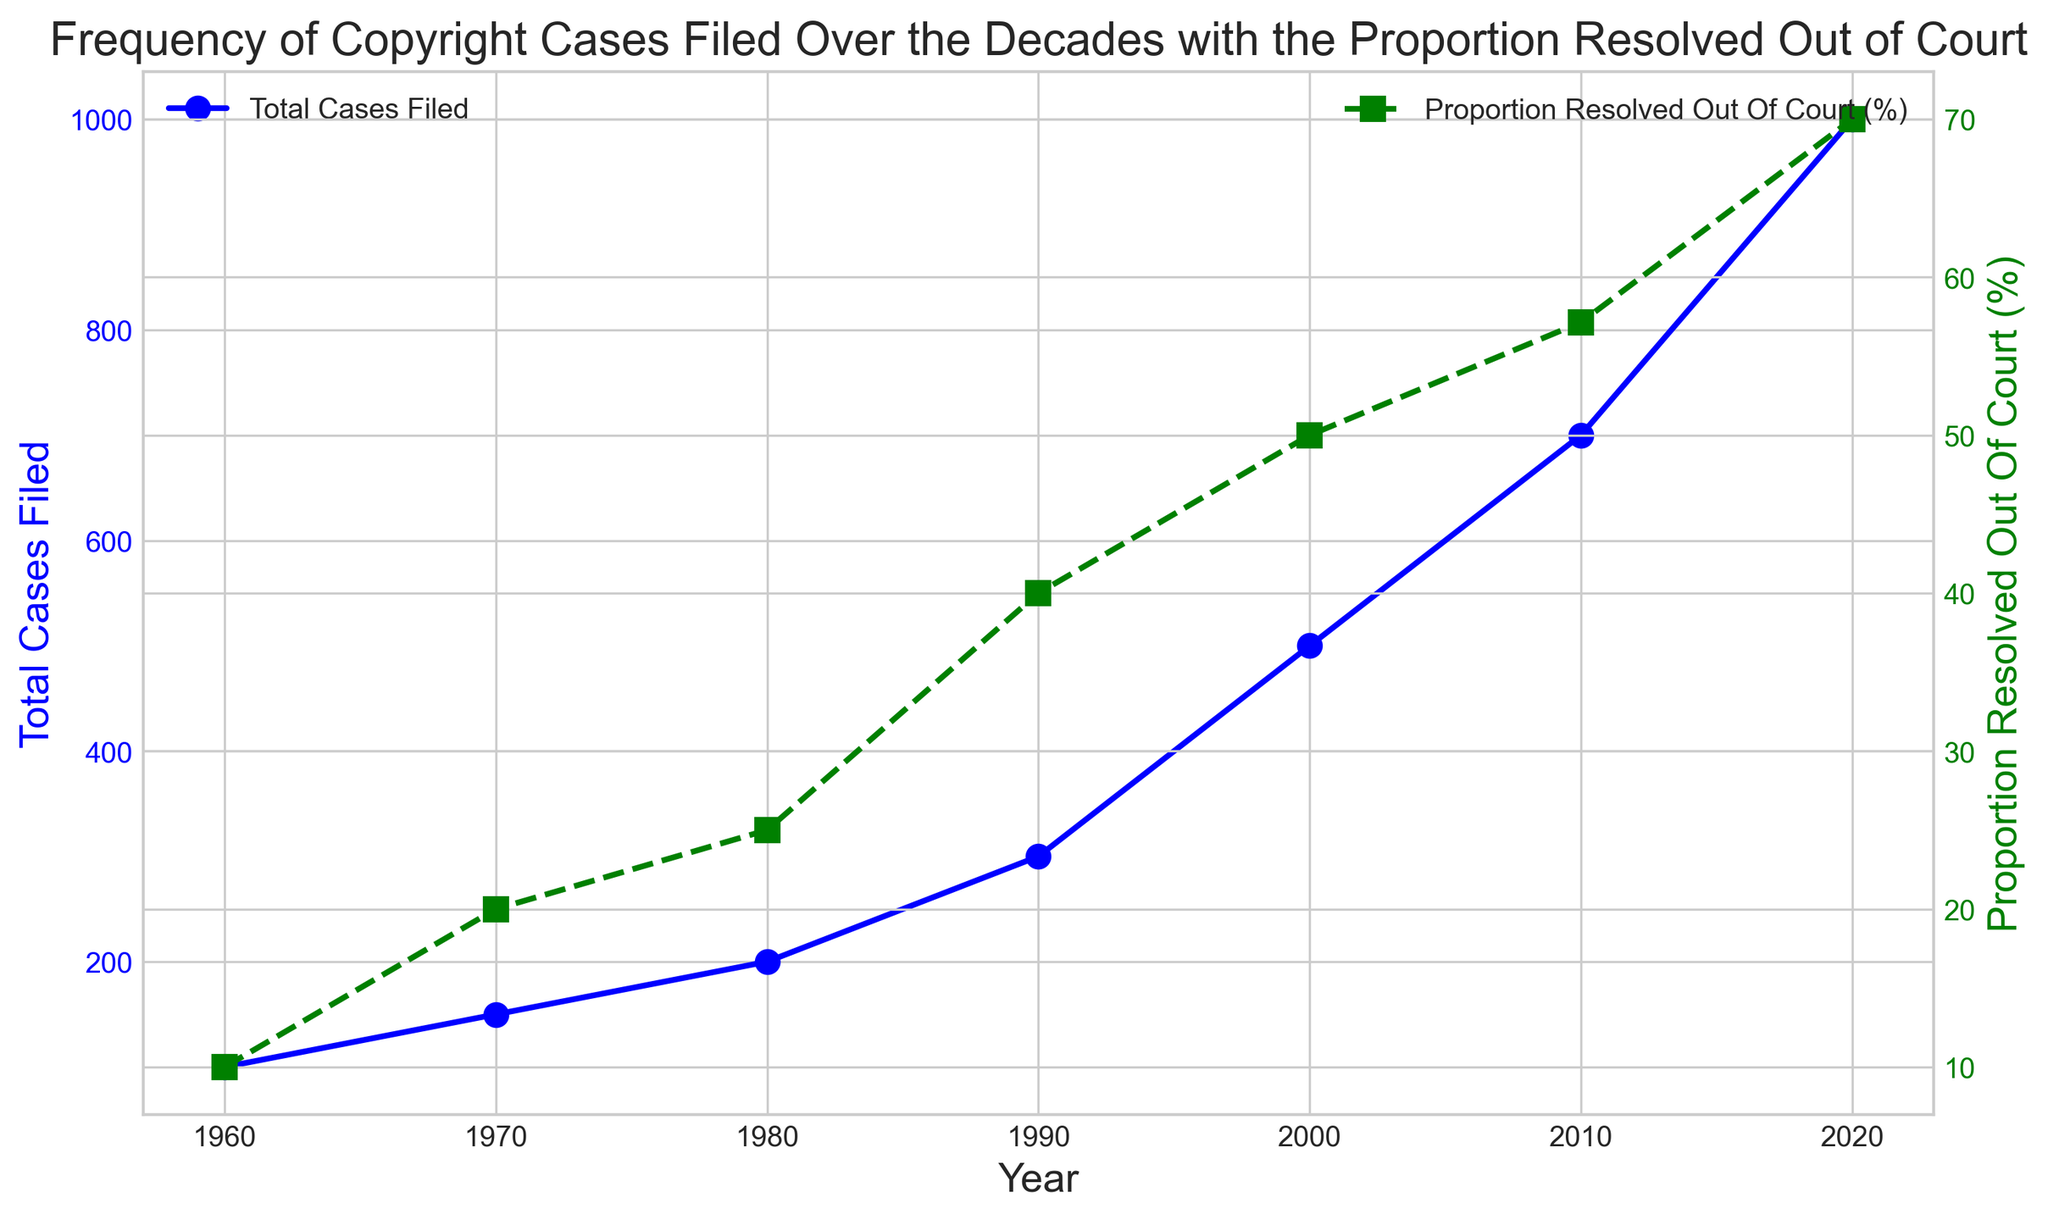What is the total number of cases filed in 1980? Refer to the blue line for 1980. The point on the vertical axis corresponds to 200, indicating 200 cases.
Answer: 200 Between 2000 and 2010, did the total number of cases filed increase or decrease? Compare the height of the blue markers for 2000 and 2010. It increased from 500 in 2000 to 700 in 2010.
Answer: Increase What is the proportion of cases resolved out of court in 1990? Look at the green line for 1990. The point lies at 40%, indicating 40%.
Answer: 40% What is the difference in the proportion of cases resolved out of court between 2000 and 2010? The green marker for 2000 is at 50%, and for 2010, it is at approximately 57.14%. The difference is 57.14% - 50%.
Answer: 7.14% Which year saw the highest proportion of cases resolved out of court? The highest green marker is in 2020 at 70%.
Answer: 2020 What was the trend in the proportion of cases resolved out of court between 1960 and 2020? Observe the green line; it generally increases across the years.
Answer: Increasing How many more total cases were filed in 2020 compared to 2010? In 2020, 1000 cases were filed, and in 2010, 700 cases were filed. The difference is 1000 - 700.
Answer: 300 What was the proportion of cases resolved out of court in 1960? The green marker for 1960 is at 10%.
Answer: 10% In which decade did the total number of cases filed experience the greatest increase? The blue markers show the largest jump between 2000 (500) and 2010 (700).
Answer: 2000-2010 What is the total number of cases resolved out of court in 2010? Using the proportion (57.14%) and the total cases (700): 57.14% of 700 = 400
Answer: 400 